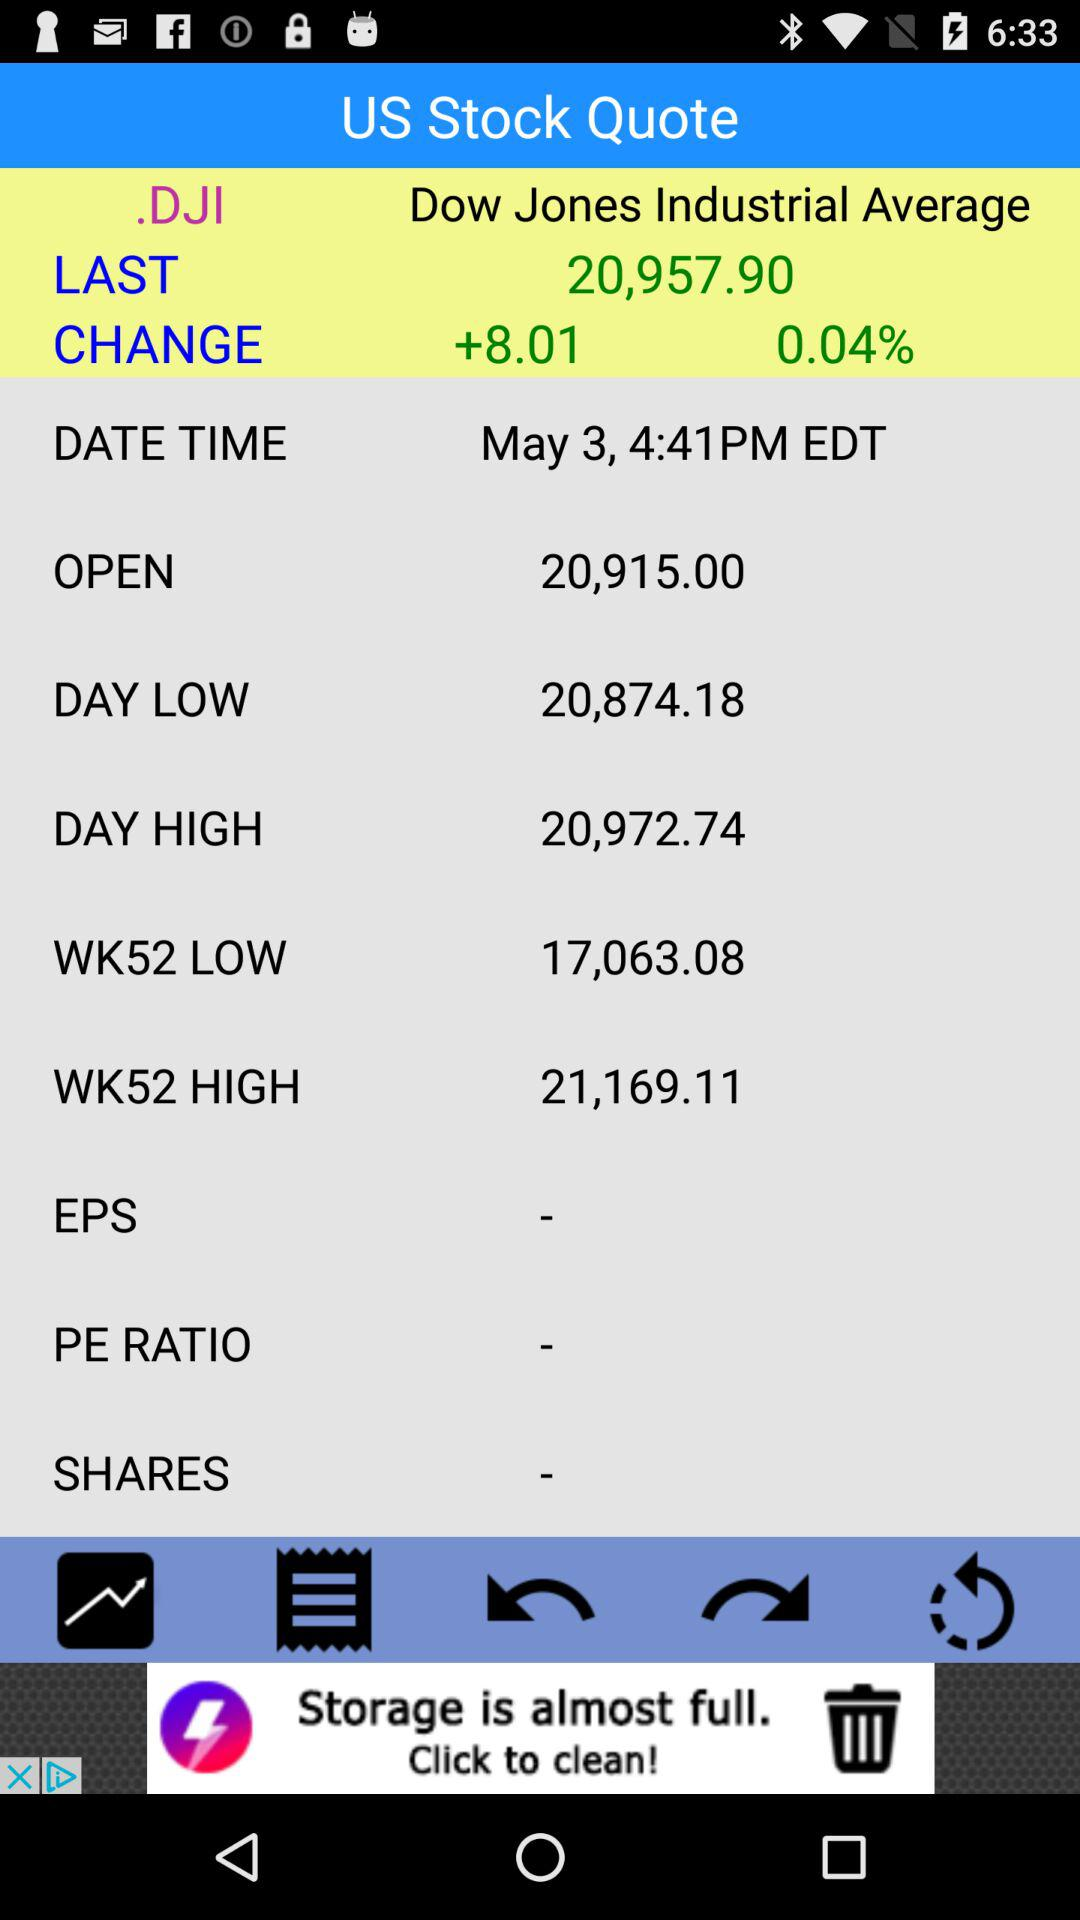What is the "DAY HIGH" amount? The "DAY HIGH" amount is 20,972.74. 